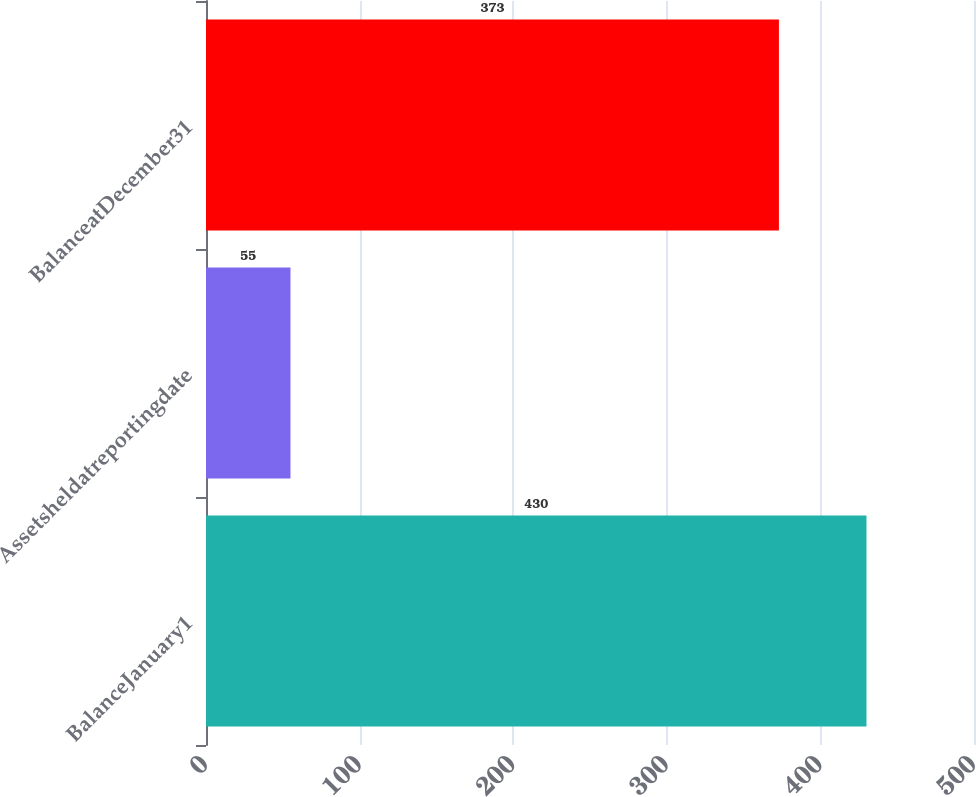<chart> <loc_0><loc_0><loc_500><loc_500><bar_chart><fcel>BalanceJanuary1<fcel>Assetsheldatreportingdate<fcel>BalanceatDecember31<nl><fcel>430<fcel>55<fcel>373<nl></chart> 